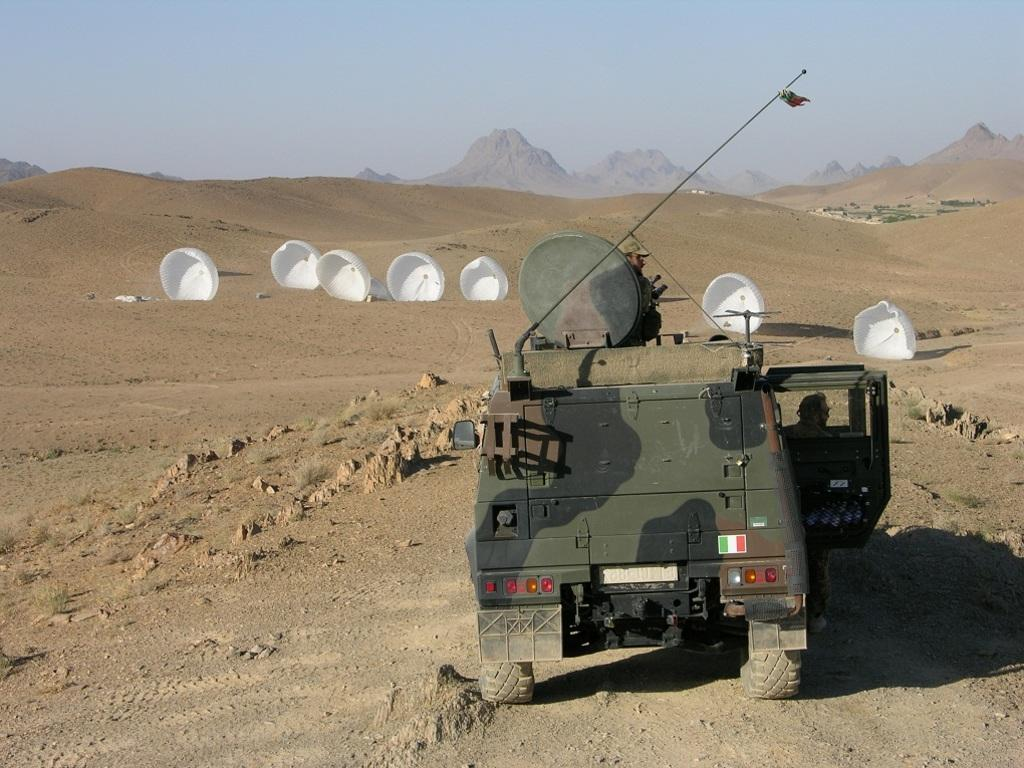What is the main subject in the image? There is a vehicle in the image. What else can be seen on the ground in the image? There are objects on the ground in the image. Are there any living beings in the image? Yes, there are people in the image. What type of natural feature is visible in the image? There are hills in the image. What type of quartz can be seen in the image? There is no quartz present in the image. How many clouds are visible in the image? There are no clouds visible in the image. 